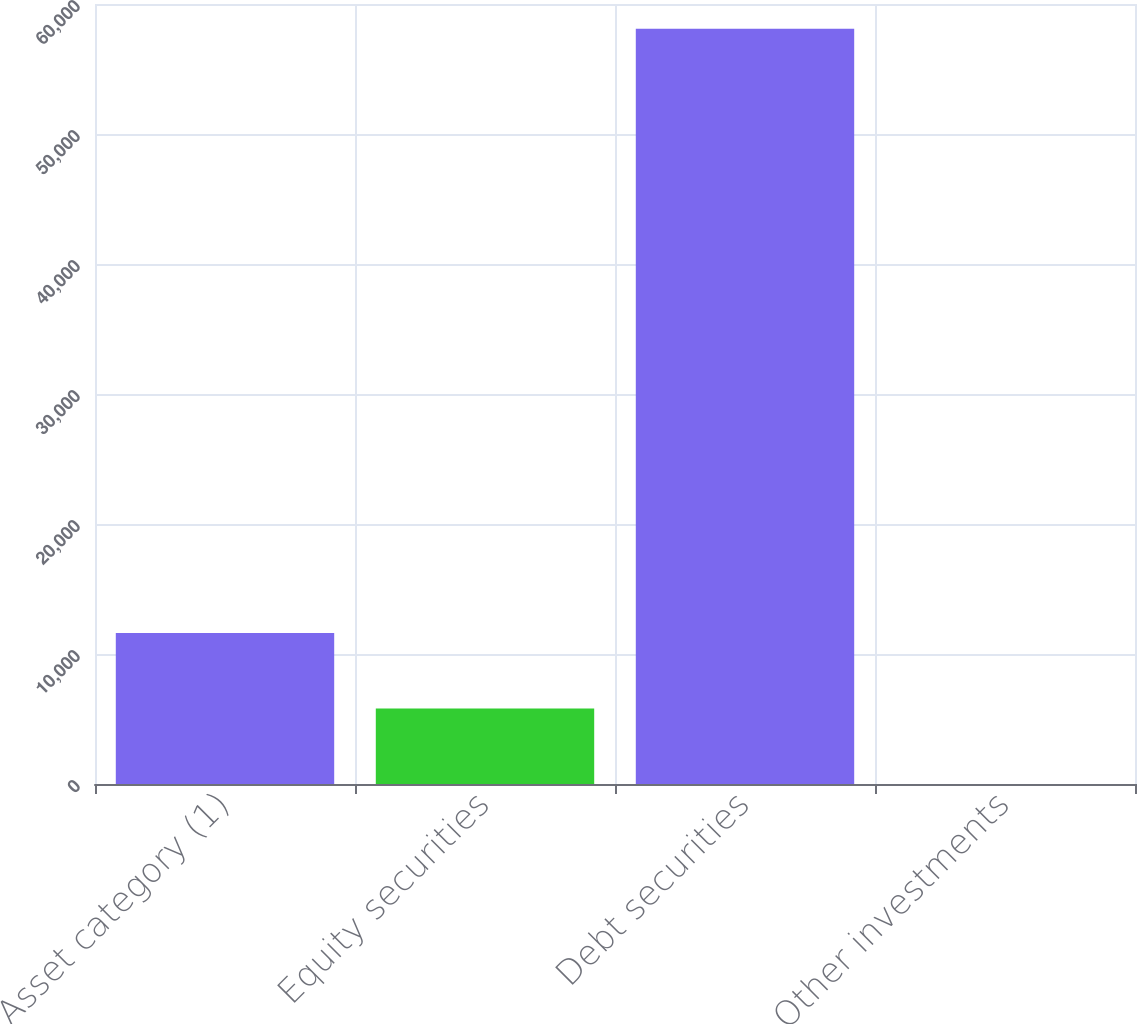Convert chart. <chart><loc_0><loc_0><loc_500><loc_500><bar_chart><fcel>Asset category (1)<fcel>Equity securities<fcel>Debt securities<fcel>Other investments<nl><fcel>11623.2<fcel>5813.6<fcel>58100<fcel>4<nl></chart> 